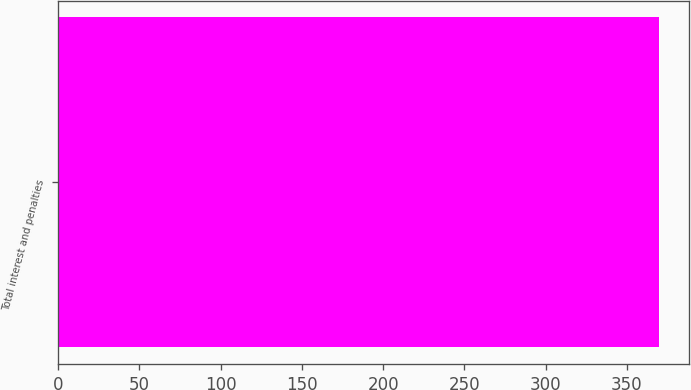Convert chart. <chart><loc_0><loc_0><loc_500><loc_500><bar_chart><fcel>Total interest and penalties<nl><fcel>370<nl></chart> 